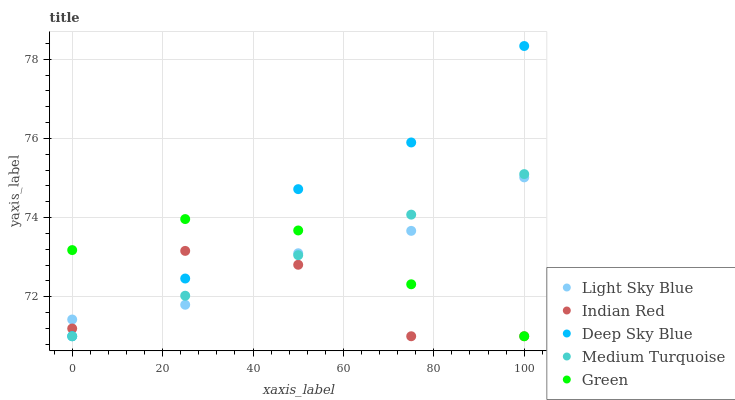Does Indian Red have the minimum area under the curve?
Answer yes or no. Yes. Does Deep Sky Blue have the maximum area under the curve?
Answer yes or no. Yes. Does Light Sky Blue have the minimum area under the curve?
Answer yes or no. No. Does Light Sky Blue have the maximum area under the curve?
Answer yes or no. No. Is Medium Turquoise the smoothest?
Answer yes or no. Yes. Is Indian Red the roughest?
Answer yes or no. Yes. Is Light Sky Blue the smoothest?
Answer yes or no. No. Is Light Sky Blue the roughest?
Answer yes or no. No. Does Medium Turquoise have the lowest value?
Answer yes or no. Yes. Does Light Sky Blue have the lowest value?
Answer yes or no. No. Does Deep Sky Blue have the highest value?
Answer yes or no. Yes. Does Light Sky Blue have the highest value?
Answer yes or no. No. Does Light Sky Blue intersect Deep Sky Blue?
Answer yes or no. Yes. Is Light Sky Blue less than Deep Sky Blue?
Answer yes or no. No. Is Light Sky Blue greater than Deep Sky Blue?
Answer yes or no. No. 